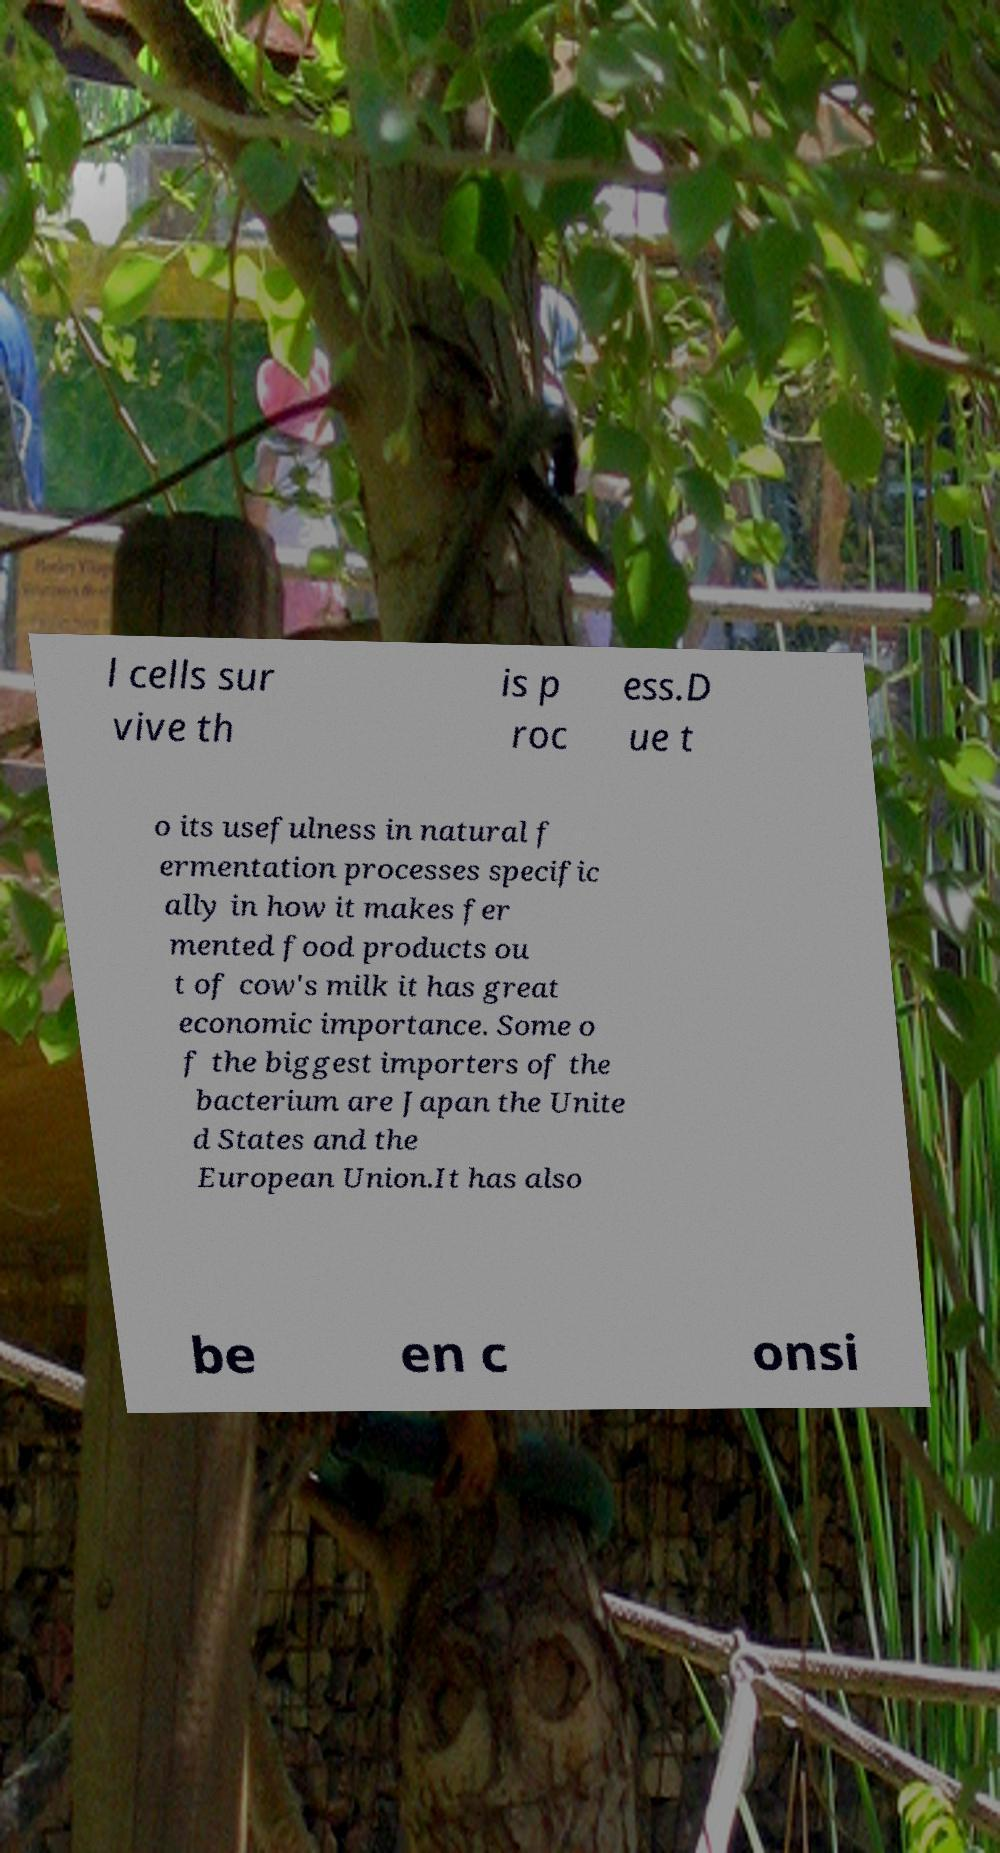Could you assist in decoding the text presented in this image and type it out clearly? l cells sur vive th is p roc ess.D ue t o its usefulness in natural f ermentation processes specific ally in how it makes fer mented food products ou t of cow's milk it has great economic importance. Some o f the biggest importers of the bacterium are Japan the Unite d States and the European Union.It has also be en c onsi 